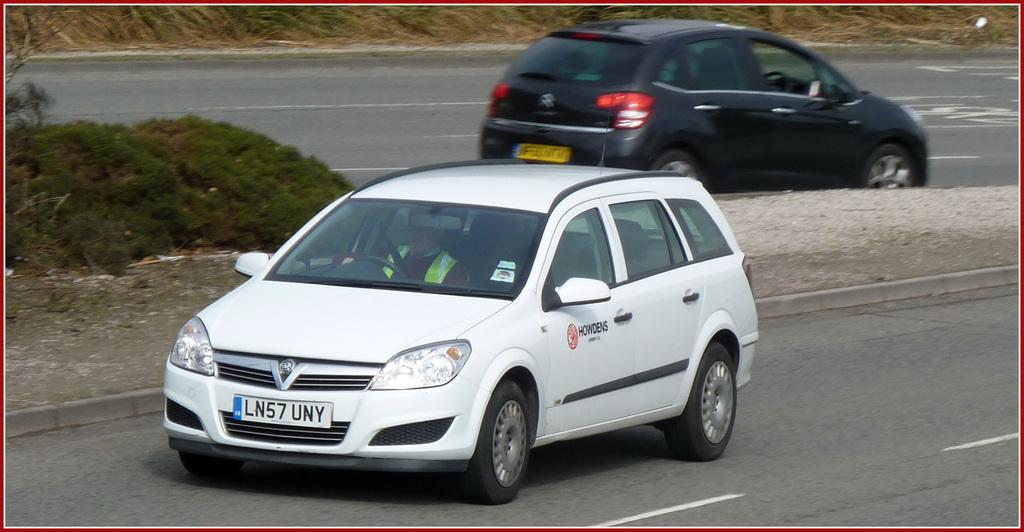<image>
Share a concise interpretation of the image provided. A white car from Howdens is driving down the road. 